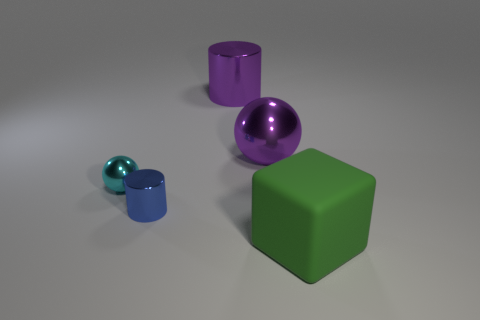Add 3 small brown rubber spheres. How many objects exist? 8 Subtract all cylinders. How many objects are left? 3 Subtract 0 red cylinders. How many objects are left? 5 Subtract all metal cylinders. Subtract all tiny objects. How many objects are left? 1 Add 1 big green matte objects. How many big green matte objects are left? 2 Add 3 cyan spheres. How many cyan spheres exist? 4 